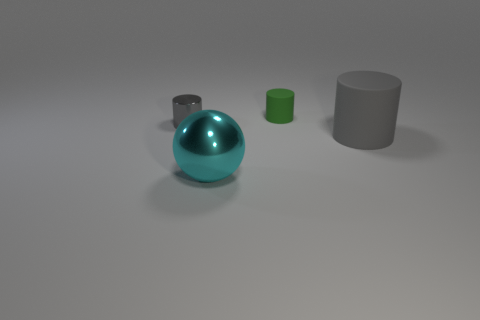What is the lighting setup like for this image? The lighting in the image seems to be set up in a way that casts soft shadows on the right side of the objects, indicating a strong light source to the left. It's diffused, creating gentle transitions on the surfaces of the objects, which is often used in studio settings to simulate a natural and soft light. 